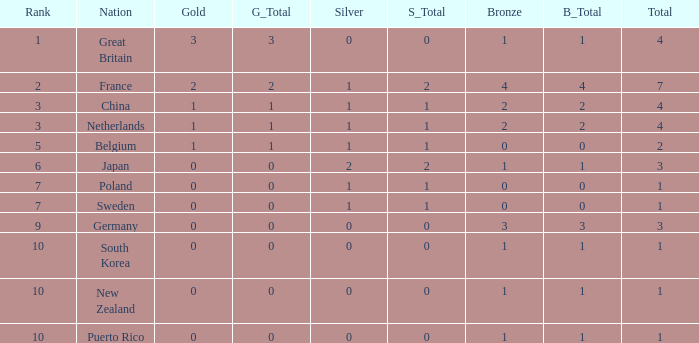What is the smallest number of gold where the total is less than 3 and the silver count is 2? None. Write the full table. {'header': ['Rank', 'Nation', 'Gold', 'G_Total', 'Silver', 'S_Total', 'Bronze', 'B_Total', 'Total'], 'rows': [['1', 'Great Britain', '3', '3', '0', '0', '1', '1', '4'], ['2', 'France', '2', '2', '1', '2', '4', '4', '7'], ['3', 'China', '1', '1', '1', '1', '2', '2', '4'], ['3', 'Netherlands', '1', '1', '1', '1', '2', '2', '4'], ['5', 'Belgium', '1', '1', '1', '1', '0', '0', '2'], ['6', 'Japan', '0', '0', '2', '2', '1', '1', '3'], ['7', 'Poland', '0', '0', '1', '1', '0', '0', '1'], ['7', 'Sweden', '0', '0', '1', '1', '0', '0', '1'], ['9', 'Germany', '0', '0', '0', '0', '3', '3', '3'], ['10', 'South Korea', '0', '0', '0', '0', '1', '1', '1'], ['10', 'New Zealand', '0', '0', '0', '0', '1', '1', '1'], ['10', 'Puerto Rico', '0', '0', '0', '0', '1', '1', '1']]} 